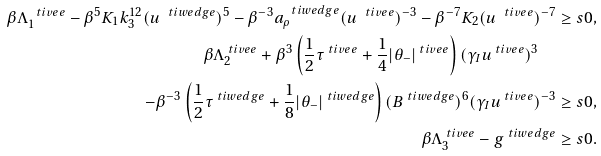<formula> <loc_0><loc_0><loc_500><loc_500>\beta \Lambda ^ { \ t i v e e } _ { 1 } - \beta ^ { 5 } K _ { 1 } k ^ { 1 2 } _ { 3 } ( u ^ { \ t i w e d g e } ) ^ { 5 } - \beta ^ { - 3 } a ^ { \ t i w e d g e } _ { \rho } ( u ^ { \ t i v e e } ) ^ { - 3 } - \beta ^ { - 7 } K _ { 2 } ( u ^ { \ t i v e e } ) ^ { - 7 } & \geq s 0 , \\ \beta \Lambda _ { 2 } ^ { \ t i v e e } + \beta ^ { 3 } \left ( \frac { 1 } { 2 } \tau ^ { \ t i v e e } + \frac { 1 } { 4 } | \theta _ { - } | ^ { \ t i v e e } \right ) ( \gamma _ { I } u ^ { \ t i v e e } ) ^ { 3 } \quad & \\ - \beta ^ { - 3 } \left ( \frac { 1 } { 2 } \tau ^ { \ t i w e d g e } + \frac { 1 } { 8 } | \theta _ { - } | ^ { \ t i w e d g e } \right ) ( B ^ { \ t i w e d g e } ) ^ { 6 } ( \gamma _ { I } u ^ { \ t i v e e } ) ^ { - 3 } & \geq s 0 , \\ \beta \Lambda ^ { \ t i v e e } _ { 3 } - g ^ { \ t i w e d g e } & \geq s 0 .</formula> 